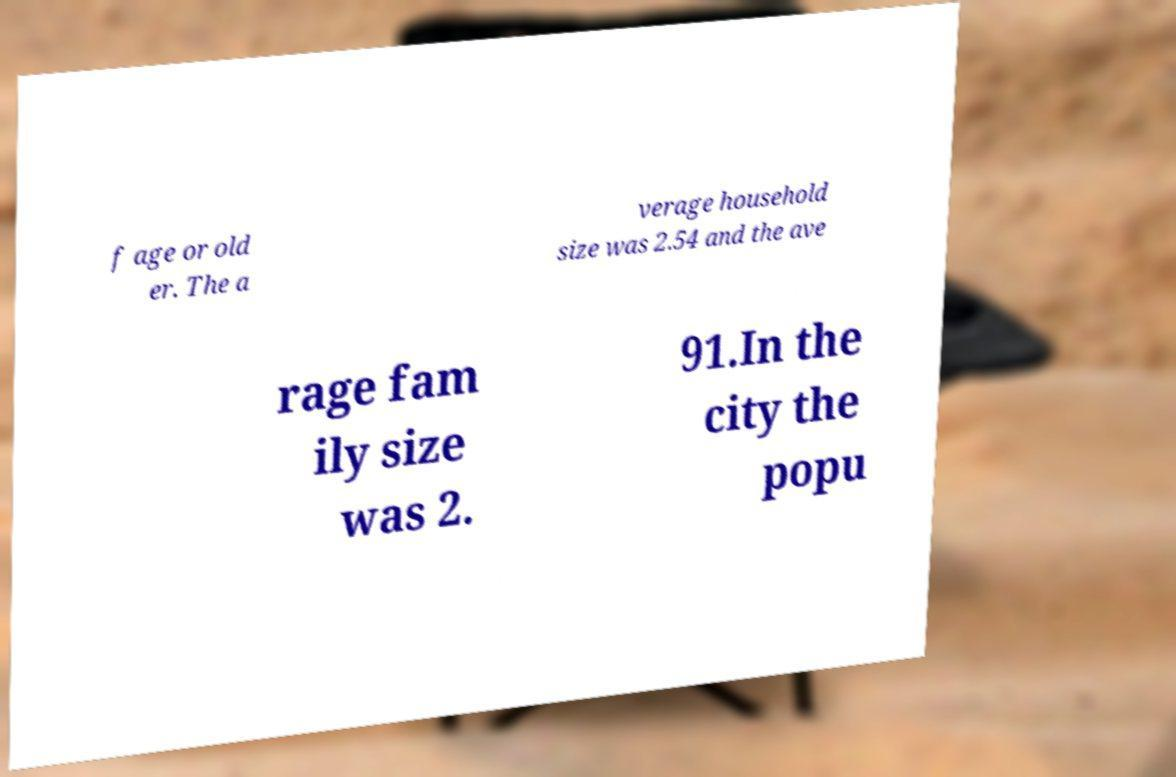Can you read and provide the text displayed in the image?This photo seems to have some interesting text. Can you extract and type it out for me? f age or old er. The a verage household size was 2.54 and the ave rage fam ily size was 2. 91.In the city the popu 